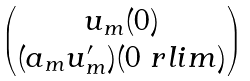<formula> <loc_0><loc_0><loc_500><loc_500>\begin{pmatrix} u _ { m } ( 0 ) \\ ( a _ { m } u _ { m } ^ { \prime } ) ( 0 \ r l i m ) \end{pmatrix}</formula> 